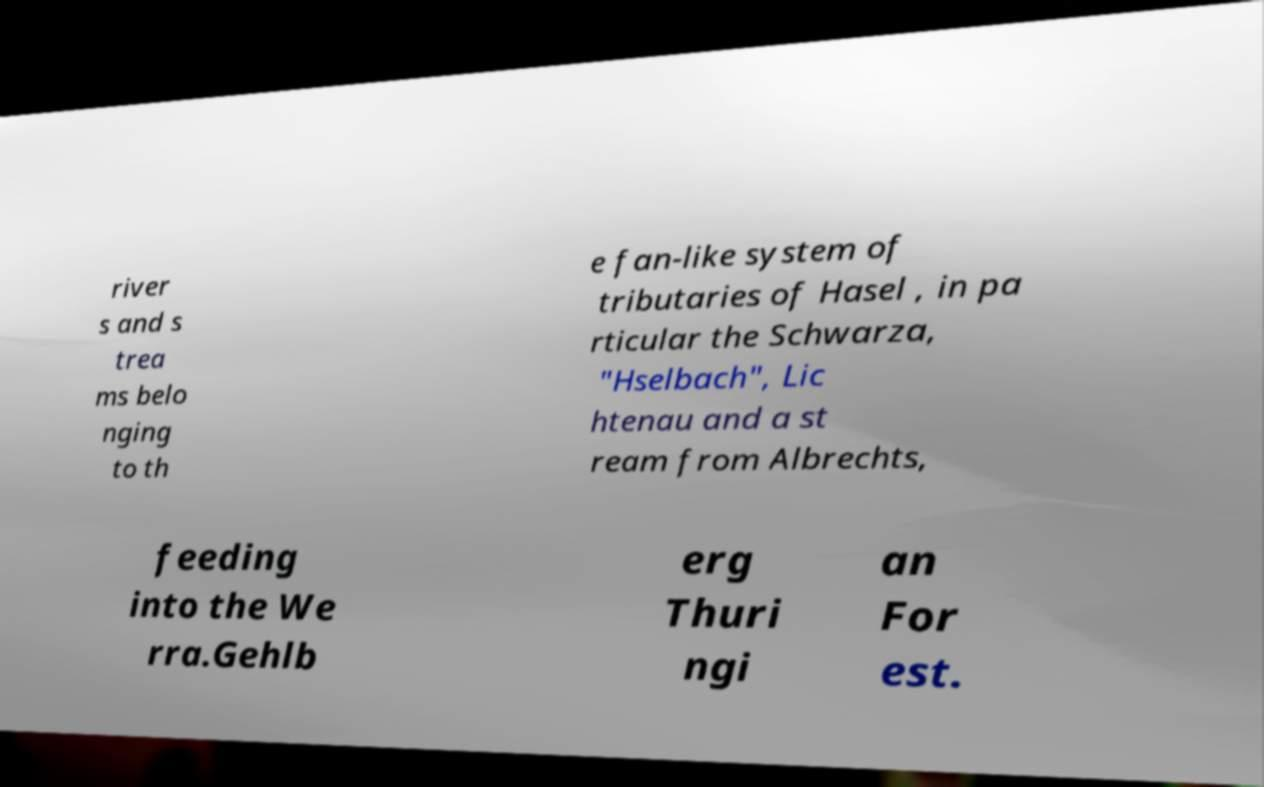I need the written content from this picture converted into text. Can you do that? river s and s trea ms belo nging to th e fan-like system of tributaries of Hasel , in pa rticular the Schwarza, "Hselbach", Lic htenau and a st ream from Albrechts, feeding into the We rra.Gehlb erg Thuri ngi an For est. 